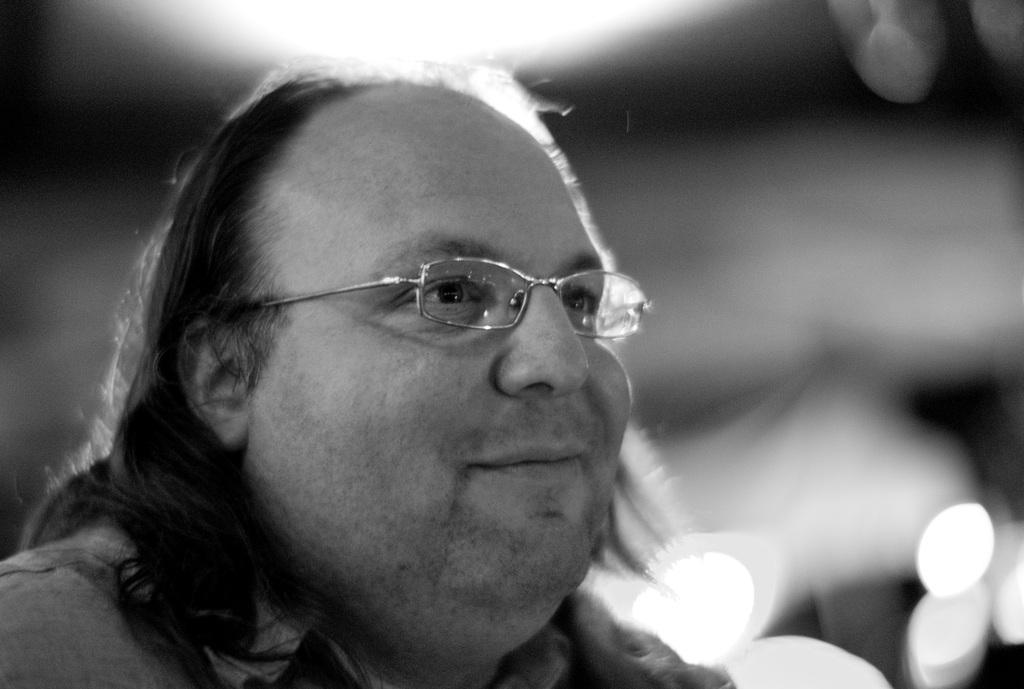Can you describe this image briefly? This is a black and white image. There is a person in this image. He is man. Only face is visible. He is the wearing specs. 